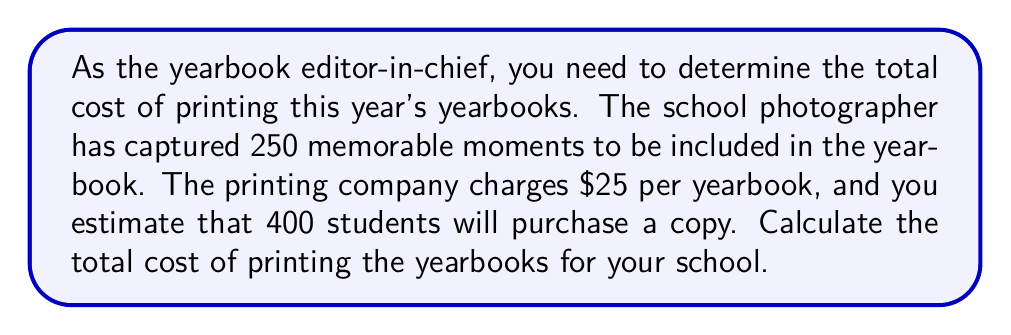Solve this math problem. To solve this problem, we need to follow these steps:

1. Identify the given information:
   - Cost per yearbook: $25
   - Number of students purchasing: 400

2. Use the formula for total cost:
   $$ \text{Total Cost} = \text{Cost per unit} \times \text{Number of units} $$

3. Plug in the values:
   $$ \text{Total Cost} = $25 \times 400 $$

4. Perform the multiplication:
   $$ \text{Total Cost} = $10,000 $$

The total cost of printing the yearbooks is $10,000. This calculation ensures that you have enough budget to print yearbooks for all 400 students who want to purchase one, preserving the 250 memorable moments captured by the school photographer.
Answer: $10,000 